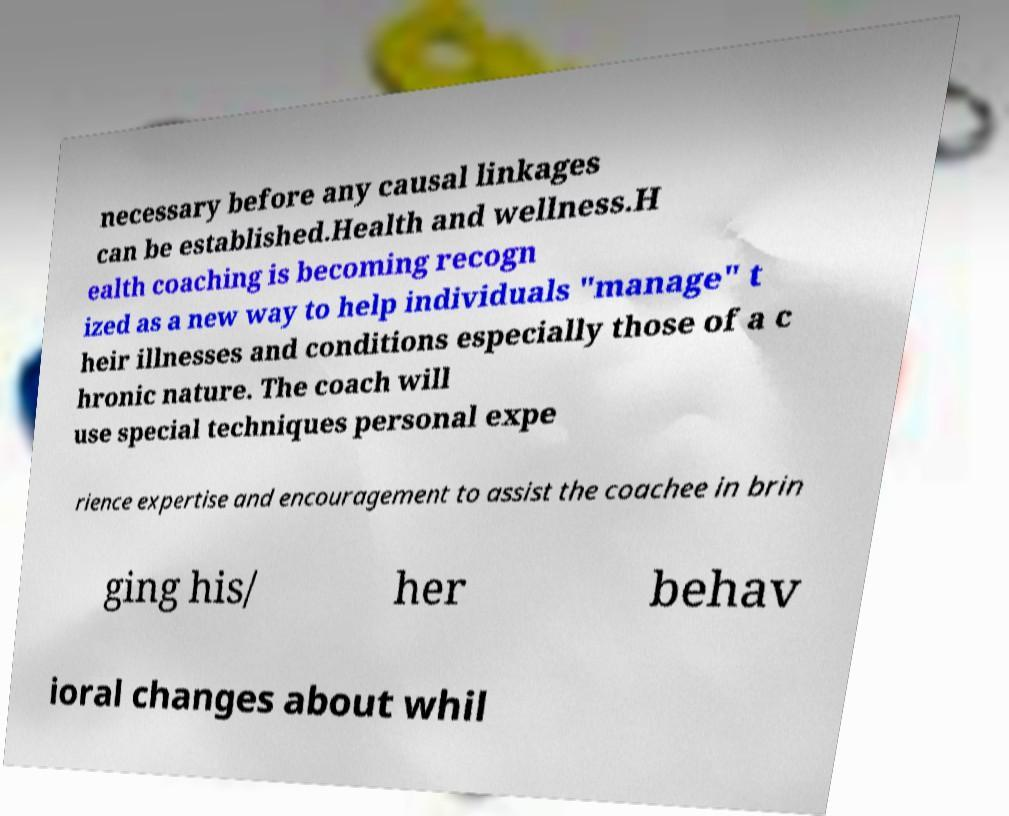Could you extract and type out the text from this image? necessary before any causal linkages can be established.Health and wellness.H ealth coaching is becoming recogn ized as a new way to help individuals "manage" t heir illnesses and conditions especially those of a c hronic nature. The coach will use special techniques personal expe rience expertise and encouragement to assist the coachee in brin ging his/ her behav ioral changes about whil 